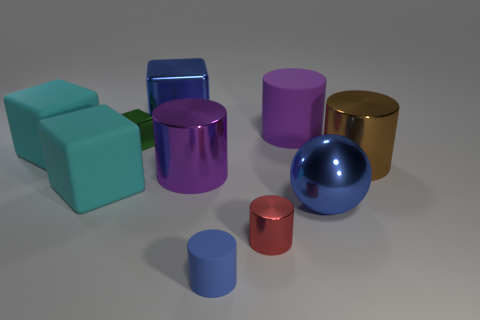How does the lighting affect the appearance of the objects? The lighting in the image appears to come from above, casting soft shadows below each object. This type of lighting enhances the three-dimensional quality of the objects, creates highlights and shadows that accentuate their colors, and gives a glossy sheen to those with reflective surfaces, adding depth and texture to the scene. 